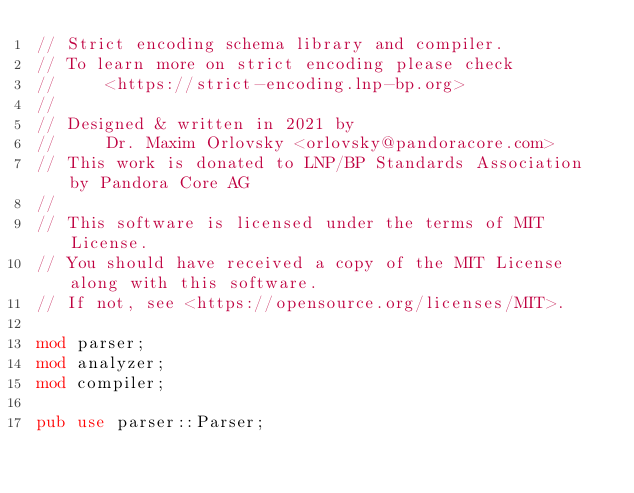Convert code to text. <code><loc_0><loc_0><loc_500><loc_500><_Rust_>// Strict encoding schema library and compiler.
// To learn more on strict encoding please check
//     <https://strict-encoding.lnp-bp.org>
//
// Designed & written in 2021 by
//     Dr. Maxim Orlovsky <orlovsky@pandoracore.com>
// This work is donated to LNP/BP Standards Association by Pandora Core AG
//
// This software is licensed under the terms of MIT License.
// You should have received a copy of the MIT License along with this software.
// If not, see <https://opensource.org/licenses/MIT>.

mod parser;
mod analyzer;
mod compiler;

pub use parser::Parser;
</code> 